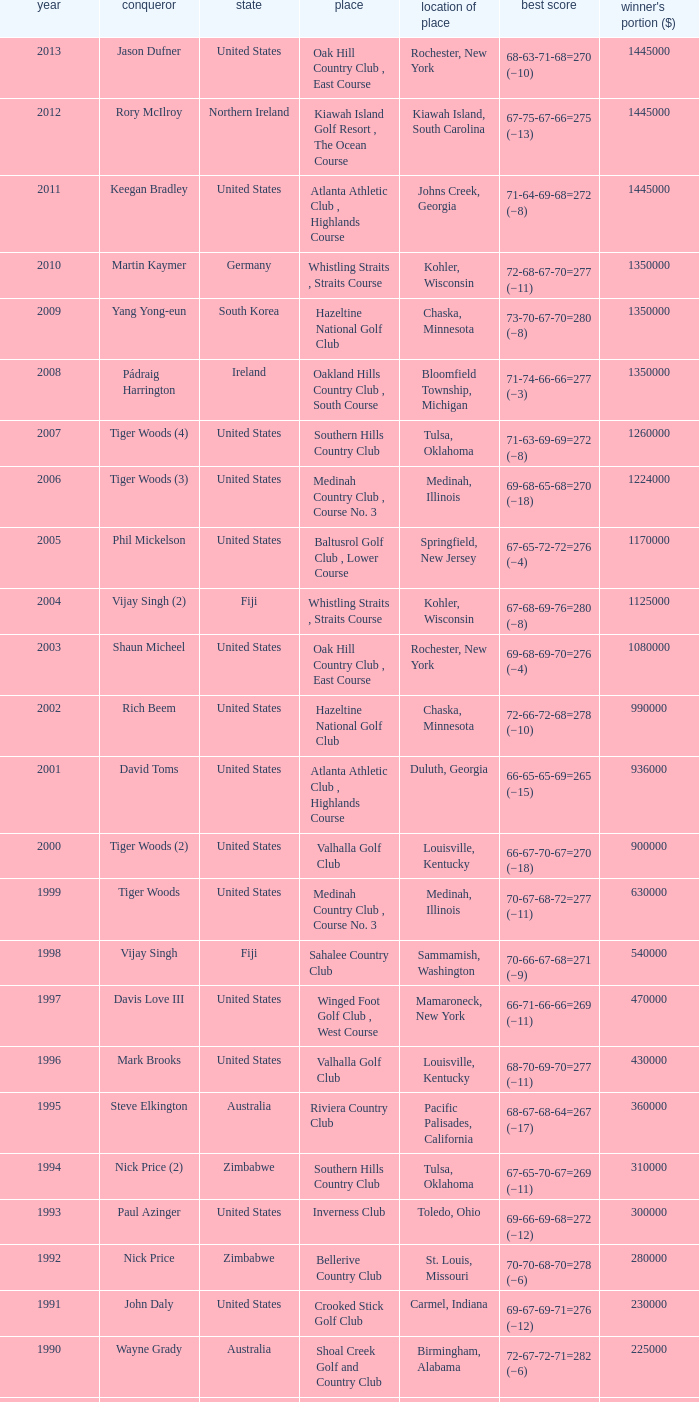Where is the Bellerive Country Club venue located? St. Louis, Missouri. 